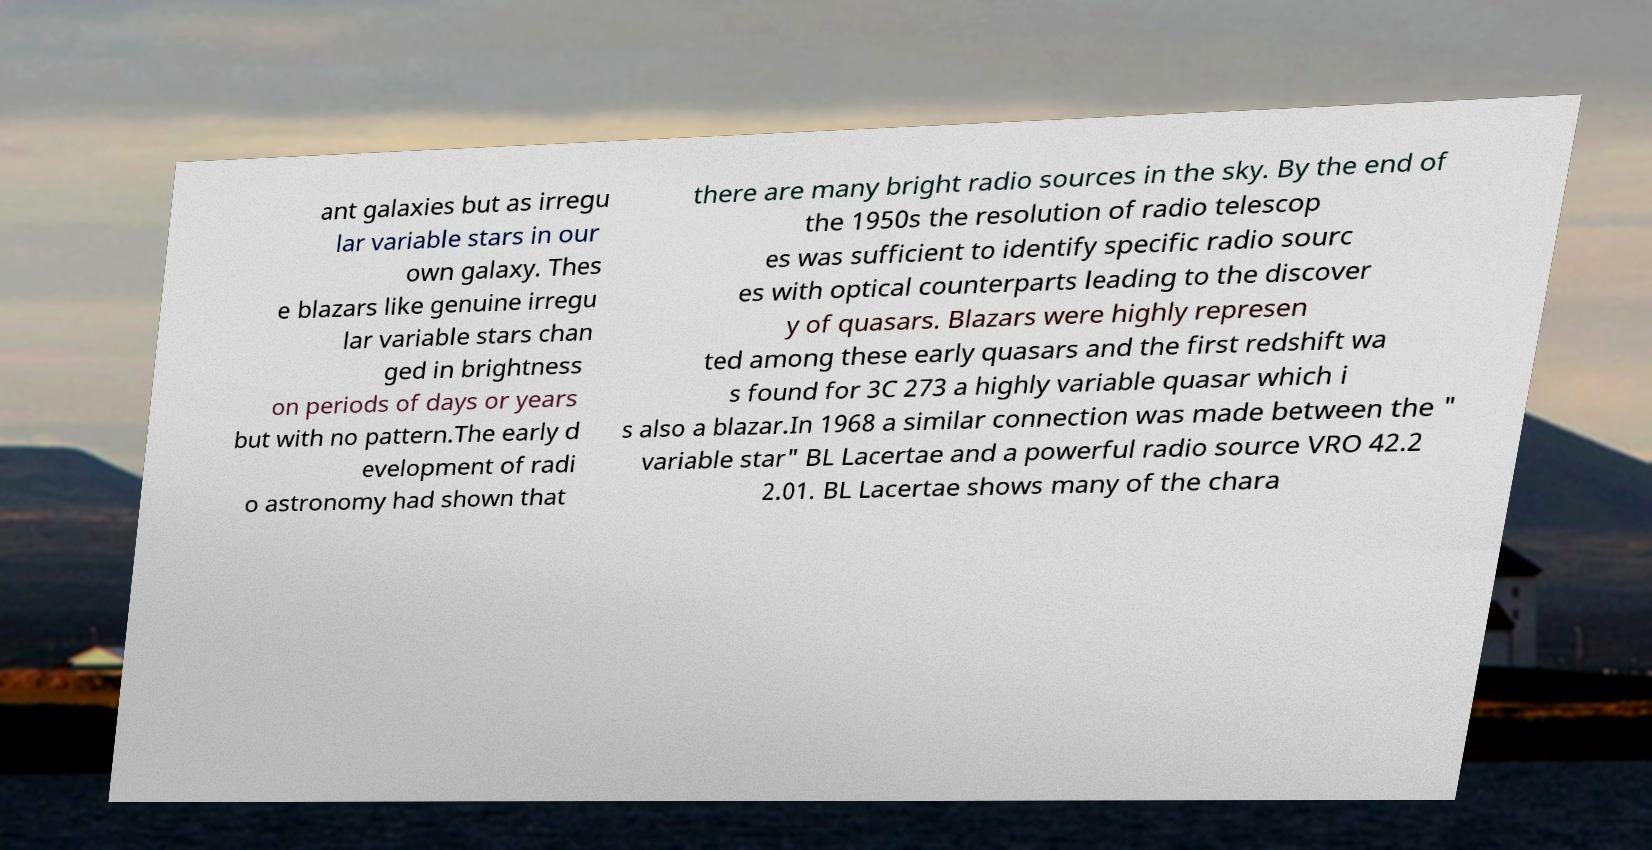Could you assist in decoding the text presented in this image and type it out clearly? ant galaxies but as irregu lar variable stars in our own galaxy. Thes e blazars like genuine irregu lar variable stars chan ged in brightness on periods of days or years but with no pattern.The early d evelopment of radi o astronomy had shown that there are many bright radio sources in the sky. By the end of the 1950s the resolution of radio telescop es was sufficient to identify specific radio sourc es with optical counterparts leading to the discover y of quasars. Blazars were highly represen ted among these early quasars and the first redshift wa s found for 3C 273 a highly variable quasar which i s also a blazar.In 1968 a similar connection was made between the " variable star" BL Lacertae and a powerful radio source VRO 42.2 2.01. BL Lacertae shows many of the chara 